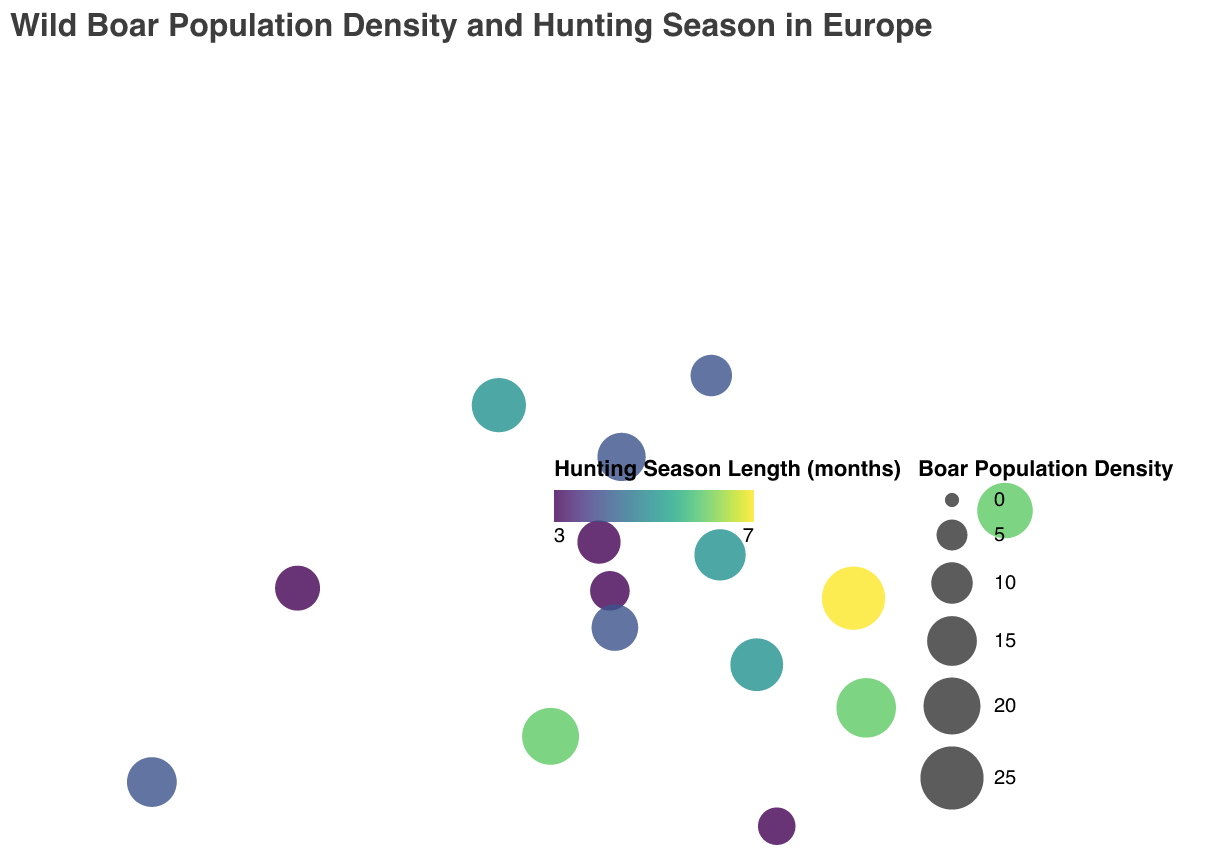What is the title of the figure? The title of the figure is displayed prominently at the top of the plot. It reads, "Wild Boar Population Density and Hunting Season in Europe."
Answer: Wild Boar Population Density and Hunting Season in Europe How many data points are shown on the map? Each data point is represented by a circle on the map, and by counting the circles, we find there are 15 data points.
Answer: 15 Which country has the highest wild boar population density, and what is its value? By looking at the size of the circles, the largest circle represents Romania. According to the tooltip, Romania has a wild boar population density of 25.
Answer: Romania, 25 Which country has the longest hunting season length, and how long is it? The color of the circle indicates hunting season length. The darkest circle corresponds to Romania, which has a hunting season length of 7 months, as shown in the tooltip.
Answer: Romania, 7 months Is there a relationship between boar population density and hunting season length? To identify a relationship, we compare the size and color of the circles. Romania, which has the highest population density, also has the longest hunting season. Several other countries with higher densities also have longer hunting seasons, indicating a potential positive correlation.
Answer: Yes, higher population densities tend to have longer hunting seasons Which country has the lowest wild boar population density? By identifying the smallest circle and verifying with the tooltip, Greece has a wild boar population density of 8, the lowest among the countries listed.
Answer: Greece Which countries have a hunting season length of 3 months? The color legend indicates that countries with a lighter color (yellow to light green) circles have shorter hunting seasons. By hovering over these circles, we identify France, Austria, Slovenia, and Greece, all with a hunting season length of 3 months.
Answer: France, Austria, Slovenia, Greece Compare the wild boar population densities of Italy and Spain. Which one is higher, and by how much? Italy has a population density of 20, while Spain has a density of 15. Subtracting these values, Italy's density is higher by 5.
Answer: Italy, by 5 What is the average hunting season length of the countries shown in the figure? Summing all hunting season lengths: 4+3+5+6+4+7+6+3+5+4+3+3+4+5+6 = 68. Dividing by the number of countries (15) gives an average: 68/15 ≈ 4.53 months.
Answer: ≈ 4.53 months 